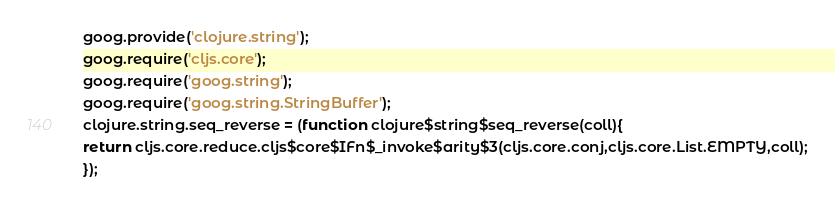<code> <loc_0><loc_0><loc_500><loc_500><_JavaScript_>goog.provide('clojure.string');
goog.require('cljs.core');
goog.require('goog.string');
goog.require('goog.string.StringBuffer');
clojure.string.seq_reverse = (function clojure$string$seq_reverse(coll){
return cljs.core.reduce.cljs$core$IFn$_invoke$arity$3(cljs.core.conj,cljs.core.List.EMPTY,coll);
});</code> 